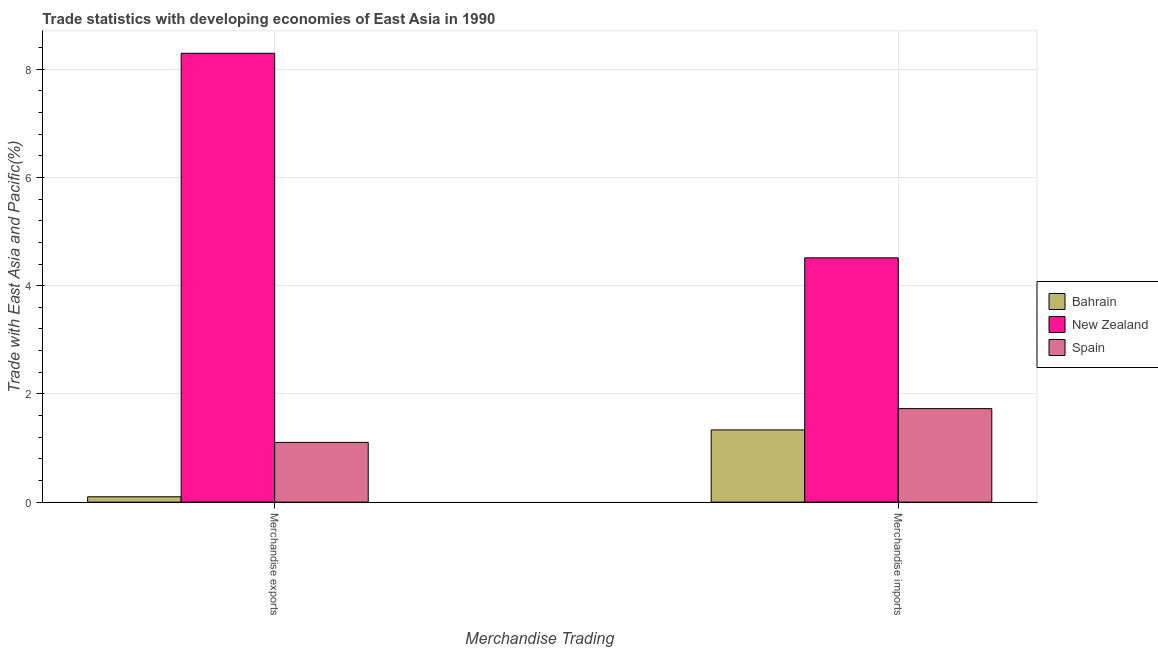How many groups of bars are there?
Your answer should be very brief. 2. Are the number of bars per tick equal to the number of legend labels?
Your answer should be compact. Yes. Are the number of bars on each tick of the X-axis equal?
Your response must be concise. Yes. How many bars are there on the 2nd tick from the left?
Provide a short and direct response. 3. How many bars are there on the 2nd tick from the right?
Give a very brief answer. 3. What is the merchandise imports in Spain?
Your answer should be very brief. 1.73. Across all countries, what is the maximum merchandise exports?
Make the answer very short. 8.3. Across all countries, what is the minimum merchandise exports?
Make the answer very short. 0.1. In which country was the merchandise exports maximum?
Make the answer very short. New Zealand. In which country was the merchandise exports minimum?
Your answer should be compact. Bahrain. What is the total merchandise exports in the graph?
Your answer should be very brief. 9.5. What is the difference between the merchandise exports in Spain and that in Bahrain?
Your answer should be compact. 1. What is the difference between the merchandise imports in Spain and the merchandise exports in New Zealand?
Your response must be concise. -6.57. What is the average merchandise imports per country?
Offer a very short reply. 2.53. What is the difference between the merchandise imports and merchandise exports in New Zealand?
Provide a succinct answer. -3.78. In how many countries, is the merchandise exports greater than 4.4 %?
Offer a very short reply. 1. What is the ratio of the merchandise imports in Spain to that in New Zealand?
Your answer should be compact. 0.38. Is the merchandise exports in Bahrain less than that in Spain?
Provide a short and direct response. Yes. What does the 3rd bar from the right in Merchandise exports represents?
Offer a terse response. Bahrain. How many countries are there in the graph?
Offer a terse response. 3. Are the values on the major ticks of Y-axis written in scientific E-notation?
Ensure brevity in your answer.  No. Does the graph contain any zero values?
Keep it short and to the point. No. Does the graph contain grids?
Ensure brevity in your answer.  Yes. Where does the legend appear in the graph?
Your response must be concise. Center right. How many legend labels are there?
Provide a succinct answer. 3. How are the legend labels stacked?
Offer a terse response. Vertical. What is the title of the graph?
Provide a short and direct response. Trade statistics with developing economies of East Asia in 1990. What is the label or title of the X-axis?
Your answer should be very brief. Merchandise Trading. What is the label or title of the Y-axis?
Provide a succinct answer. Trade with East Asia and Pacific(%). What is the Trade with East Asia and Pacific(%) in Bahrain in Merchandise exports?
Your response must be concise. 0.1. What is the Trade with East Asia and Pacific(%) of New Zealand in Merchandise exports?
Keep it short and to the point. 8.3. What is the Trade with East Asia and Pacific(%) of Spain in Merchandise exports?
Ensure brevity in your answer.  1.1. What is the Trade with East Asia and Pacific(%) of Bahrain in Merchandise imports?
Your response must be concise. 1.33. What is the Trade with East Asia and Pacific(%) of New Zealand in Merchandise imports?
Give a very brief answer. 4.52. What is the Trade with East Asia and Pacific(%) in Spain in Merchandise imports?
Provide a short and direct response. 1.73. Across all Merchandise Trading, what is the maximum Trade with East Asia and Pacific(%) in Bahrain?
Offer a terse response. 1.33. Across all Merchandise Trading, what is the maximum Trade with East Asia and Pacific(%) in New Zealand?
Provide a succinct answer. 8.3. Across all Merchandise Trading, what is the maximum Trade with East Asia and Pacific(%) in Spain?
Give a very brief answer. 1.73. Across all Merchandise Trading, what is the minimum Trade with East Asia and Pacific(%) of Bahrain?
Keep it short and to the point. 0.1. Across all Merchandise Trading, what is the minimum Trade with East Asia and Pacific(%) in New Zealand?
Give a very brief answer. 4.52. Across all Merchandise Trading, what is the minimum Trade with East Asia and Pacific(%) in Spain?
Offer a very short reply. 1.1. What is the total Trade with East Asia and Pacific(%) in Bahrain in the graph?
Your answer should be very brief. 1.43. What is the total Trade with East Asia and Pacific(%) of New Zealand in the graph?
Your answer should be very brief. 12.81. What is the total Trade with East Asia and Pacific(%) in Spain in the graph?
Your answer should be compact. 2.83. What is the difference between the Trade with East Asia and Pacific(%) of Bahrain in Merchandise exports and that in Merchandise imports?
Offer a very short reply. -1.24. What is the difference between the Trade with East Asia and Pacific(%) of New Zealand in Merchandise exports and that in Merchandise imports?
Give a very brief answer. 3.78. What is the difference between the Trade with East Asia and Pacific(%) of Spain in Merchandise exports and that in Merchandise imports?
Your answer should be compact. -0.62. What is the difference between the Trade with East Asia and Pacific(%) in Bahrain in Merchandise exports and the Trade with East Asia and Pacific(%) in New Zealand in Merchandise imports?
Give a very brief answer. -4.42. What is the difference between the Trade with East Asia and Pacific(%) in Bahrain in Merchandise exports and the Trade with East Asia and Pacific(%) in Spain in Merchandise imports?
Offer a very short reply. -1.63. What is the difference between the Trade with East Asia and Pacific(%) of New Zealand in Merchandise exports and the Trade with East Asia and Pacific(%) of Spain in Merchandise imports?
Your response must be concise. 6.57. What is the average Trade with East Asia and Pacific(%) of Bahrain per Merchandise Trading?
Make the answer very short. 0.72. What is the average Trade with East Asia and Pacific(%) of New Zealand per Merchandise Trading?
Give a very brief answer. 6.41. What is the average Trade with East Asia and Pacific(%) of Spain per Merchandise Trading?
Your response must be concise. 1.42. What is the difference between the Trade with East Asia and Pacific(%) in Bahrain and Trade with East Asia and Pacific(%) in New Zealand in Merchandise exports?
Ensure brevity in your answer.  -8.2. What is the difference between the Trade with East Asia and Pacific(%) in Bahrain and Trade with East Asia and Pacific(%) in Spain in Merchandise exports?
Your response must be concise. -1. What is the difference between the Trade with East Asia and Pacific(%) of New Zealand and Trade with East Asia and Pacific(%) of Spain in Merchandise exports?
Your response must be concise. 7.19. What is the difference between the Trade with East Asia and Pacific(%) of Bahrain and Trade with East Asia and Pacific(%) of New Zealand in Merchandise imports?
Your response must be concise. -3.18. What is the difference between the Trade with East Asia and Pacific(%) of Bahrain and Trade with East Asia and Pacific(%) of Spain in Merchandise imports?
Your response must be concise. -0.39. What is the difference between the Trade with East Asia and Pacific(%) in New Zealand and Trade with East Asia and Pacific(%) in Spain in Merchandise imports?
Provide a succinct answer. 2.79. What is the ratio of the Trade with East Asia and Pacific(%) in Bahrain in Merchandise exports to that in Merchandise imports?
Provide a succinct answer. 0.07. What is the ratio of the Trade with East Asia and Pacific(%) in New Zealand in Merchandise exports to that in Merchandise imports?
Provide a short and direct response. 1.84. What is the ratio of the Trade with East Asia and Pacific(%) in Spain in Merchandise exports to that in Merchandise imports?
Provide a short and direct response. 0.64. What is the difference between the highest and the second highest Trade with East Asia and Pacific(%) in Bahrain?
Offer a terse response. 1.24. What is the difference between the highest and the second highest Trade with East Asia and Pacific(%) in New Zealand?
Offer a very short reply. 3.78. What is the difference between the highest and the second highest Trade with East Asia and Pacific(%) in Spain?
Give a very brief answer. 0.62. What is the difference between the highest and the lowest Trade with East Asia and Pacific(%) in Bahrain?
Ensure brevity in your answer.  1.24. What is the difference between the highest and the lowest Trade with East Asia and Pacific(%) in New Zealand?
Offer a very short reply. 3.78. What is the difference between the highest and the lowest Trade with East Asia and Pacific(%) in Spain?
Give a very brief answer. 0.62. 